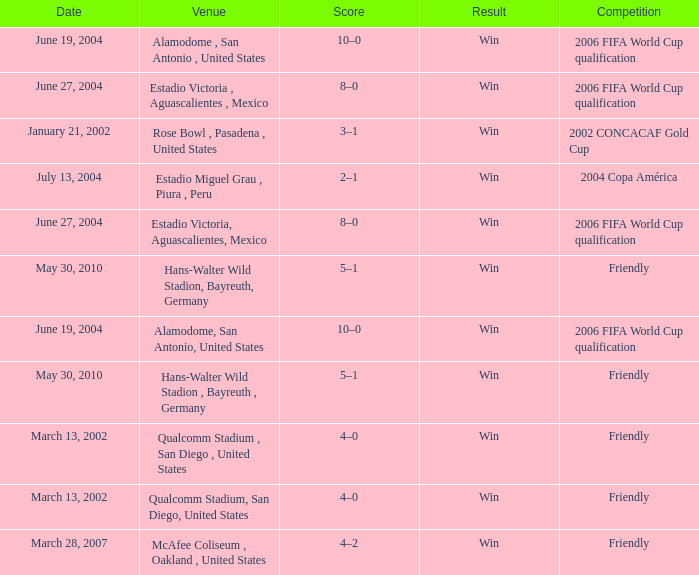What result has January 21, 2002 as the date? Win. 